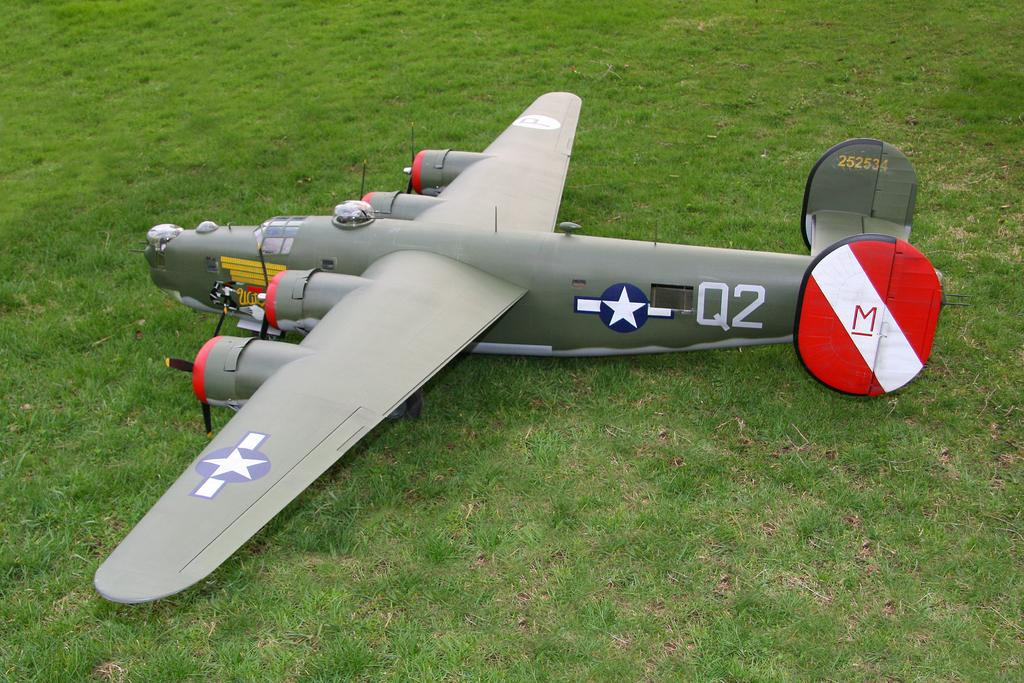What is the main subject of the image? There is an aircraft in the image. What type of environment is visible in the image? There is grass visible in the image. What type of bird can be seen perched on the roof in the image? There is no bird or roof present in the image; it features an aircraft and grass. How does the image make you feel, considering the emotion of disgust? The image does not evoke any specific emotions, such as disgust, as it only contains an aircraft and grass. 